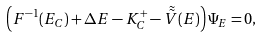Convert formula to latex. <formula><loc_0><loc_0><loc_500><loc_500>\left ( F ^ { - 1 } ( E _ { C } ) + \Delta E - K ^ { + } _ { C } - \tilde { \tilde { V } } ( E ) \right ) \Psi _ { E } = 0 ,</formula> 